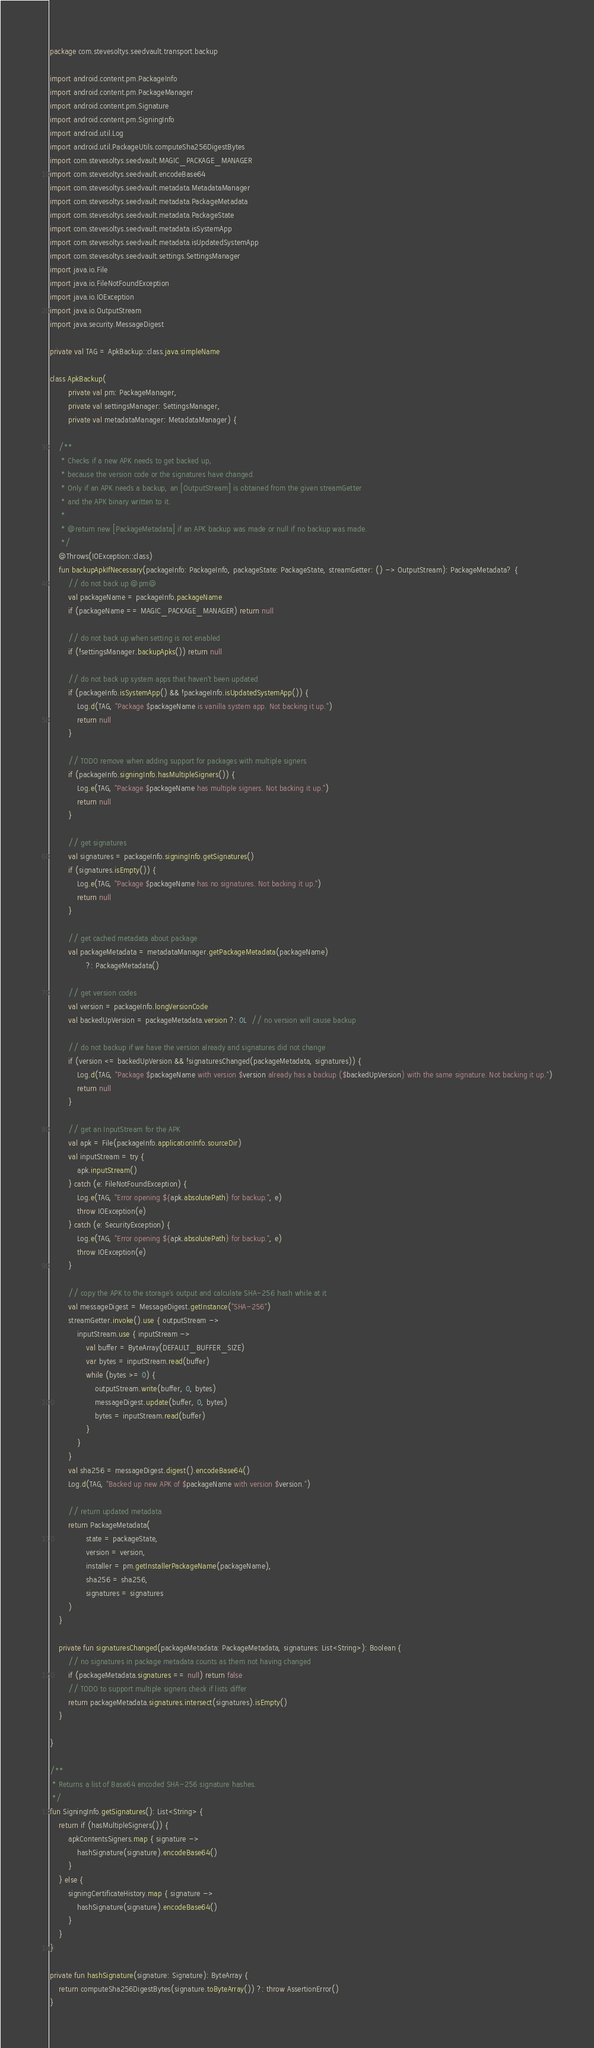Convert code to text. <code><loc_0><loc_0><loc_500><loc_500><_Kotlin_>package com.stevesoltys.seedvault.transport.backup

import android.content.pm.PackageInfo
import android.content.pm.PackageManager
import android.content.pm.Signature
import android.content.pm.SigningInfo
import android.util.Log
import android.util.PackageUtils.computeSha256DigestBytes
import com.stevesoltys.seedvault.MAGIC_PACKAGE_MANAGER
import com.stevesoltys.seedvault.encodeBase64
import com.stevesoltys.seedvault.metadata.MetadataManager
import com.stevesoltys.seedvault.metadata.PackageMetadata
import com.stevesoltys.seedvault.metadata.PackageState
import com.stevesoltys.seedvault.metadata.isSystemApp
import com.stevesoltys.seedvault.metadata.isUpdatedSystemApp
import com.stevesoltys.seedvault.settings.SettingsManager
import java.io.File
import java.io.FileNotFoundException
import java.io.IOException
import java.io.OutputStream
import java.security.MessageDigest

private val TAG = ApkBackup::class.java.simpleName

class ApkBackup(
        private val pm: PackageManager,
        private val settingsManager: SettingsManager,
        private val metadataManager: MetadataManager) {

    /**
     * Checks if a new APK needs to get backed up,
     * because the version code or the signatures have changed.
     * Only if an APK needs a backup, an [OutputStream] is obtained from the given streamGetter
     * and the APK binary written to it.
     *
     * @return new [PackageMetadata] if an APK backup was made or null if no backup was made.
     */
    @Throws(IOException::class)
    fun backupApkIfNecessary(packageInfo: PackageInfo, packageState: PackageState, streamGetter: () -> OutputStream): PackageMetadata? {
        // do not back up @pm@
        val packageName = packageInfo.packageName
        if (packageName == MAGIC_PACKAGE_MANAGER) return null

        // do not back up when setting is not enabled
        if (!settingsManager.backupApks()) return null

        // do not back up system apps that haven't been updated
        if (packageInfo.isSystemApp() && !packageInfo.isUpdatedSystemApp()) {
            Log.d(TAG, "Package $packageName is vanilla system app. Not backing it up.")
            return null
        }

        // TODO remove when adding support for packages with multiple signers
        if (packageInfo.signingInfo.hasMultipleSigners()) {
            Log.e(TAG, "Package $packageName has multiple signers. Not backing it up.")
            return null
        }

        // get signatures
        val signatures = packageInfo.signingInfo.getSignatures()
        if (signatures.isEmpty()) {
            Log.e(TAG, "Package $packageName has no signatures. Not backing it up.")
            return null
        }

        // get cached metadata about package
        val packageMetadata = metadataManager.getPackageMetadata(packageName)
                ?: PackageMetadata()

        // get version codes
        val version = packageInfo.longVersionCode
        val backedUpVersion = packageMetadata.version ?: 0L  // no version will cause backup

        // do not backup if we have the version already and signatures did not change
        if (version <= backedUpVersion && !signaturesChanged(packageMetadata, signatures)) {
            Log.d(TAG, "Package $packageName with version $version already has a backup ($backedUpVersion) with the same signature. Not backing it up.")
            return null
        }

        // get an InputStream for the APK
        val apk = File(packageInfo.applicationInfo.sourceDir)
        val inputStream = try {
            apk.inputStream()
        } catch (e: FileNotFoundException) {
            Log.e(TAG, "Error opening ${apk.absolutePath} for backup.", e)
            throw IOException(e)
        } catch (e: SecurityException) {
            Log.e(TAG, "Error opening ${apk.absolutePath} for backup.", e)
            throw IOException(e)
        }

        // copy the APK to the storage's output and calculate SHA-256 hash while at it
        val messageDigest = MessageDigest.getInstance("SHA-256")
        streamGetter.invoke().use { outputStream ->
            inputStream.use { inputStream ->
                val buffer = ByteArray(DEFAULT_BUFFER_SIZE)
                var bytes = inputStream.read(buffer)
                while (bytes >= 0) {
                    outputStream.write(buffer, 0, bytes)
                    messageDigest.update(buffer, 0, bytes)
                    bytes = inputStream.read(buffer)
                }
            }
        }
        val sha256 = messageDigest.digest().encodeBase64()
        Log.d(TAG, "Backed up new APK of $packageName with version $version.")

        // return updated metadata
        return PackageMetadata(
                state = packageState,
                version = version,
                installer = pm.getInstallerPackageName(packageName),
                sha256 = sha256,
                signatures = signatures
        )
    }

    private fun signaturesChanged(packageMetadata: PackageMetadata, signatures: List<String>): Boolean {
        // no signatures in package metadata counts as them not having changed
        if (packageMetadata.signatures == null) return false
        // TODO to support multiple signers check if lists differ
        return packageMetadata.signatures.intersect(signatures).isEmpty()
    }

}

/**
 * Returns a list of Base64 encoded SHA-256 signature hashes.
 */
fun SigningInfo.getSignatures(): List<String> {
    return if (hasMultipleSigners()) {
        apkContentsSigners.map { signature ->
            hashSignature(signature).encodeBase64()
        }
    } else {
        signingCertificateHistory.map { signature ->
            hashSignature(signature).encodeBase64()
        }
    }
}

private fun hashSignature(signature: Signature): ByteArray {
    return computeSha256DigestBytes(signature.toByteArray()) ?: throw AssertionError()
}
</code> 